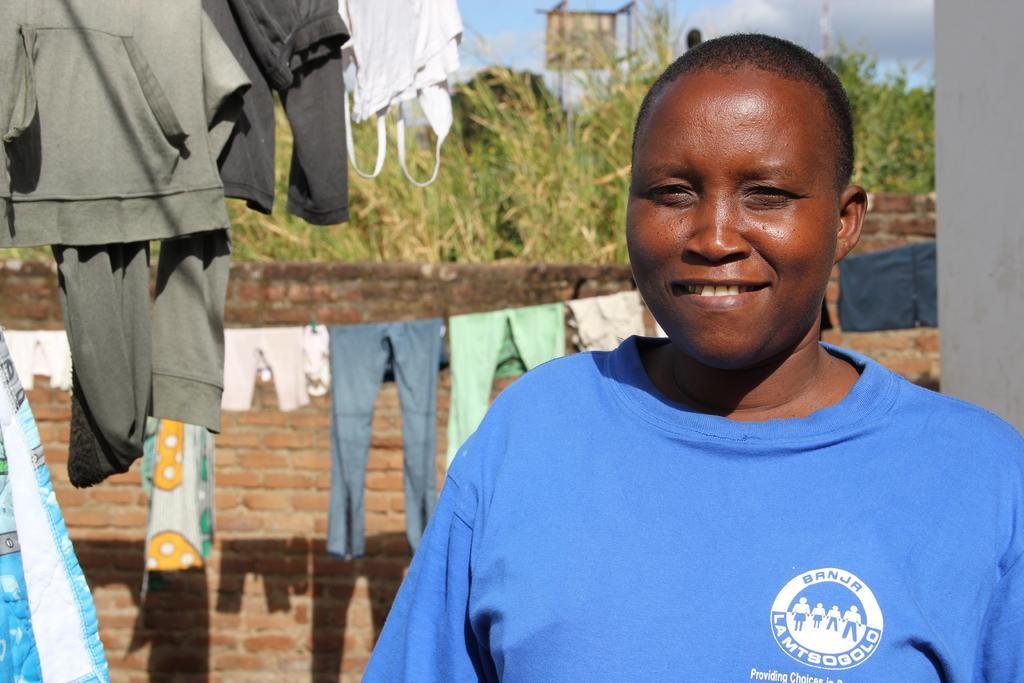Can you describe this image briefly? In this image we can see a person. There are many clothes hanged on the rope. There is a wall in the image. There is a blue and a slightly cloudy sky in the image. There are many plants in the image. 